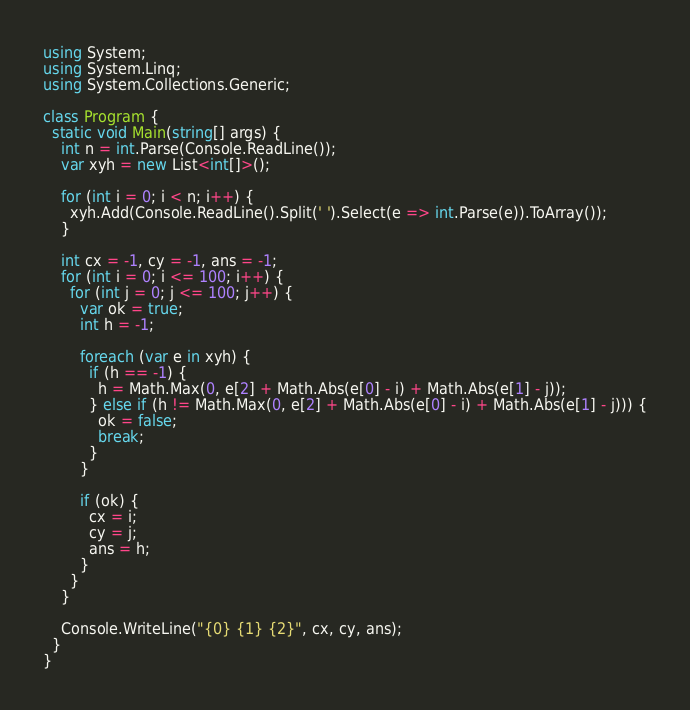<code> <loc_0><loc_0><loc_500><loc_500><_C#_>using System;
using System.Linq;
using System.Collections.Generic;

class Program {
  static void Main(string[] args) {
    int n = int.Parse(Console.ReadLine());
    var xyh = new List<int[]>();

    for (int i = 0; i < n; i++) {
      xyh.Add(Console.ReadLine().Split(' ').Select(e => int.Parse(e)).ToArray());
    }

    int cx = -1, cy = -1, ans = -1;
    for (int i = 0; i <= 100; i++) {
      for (int j = 0; j <= 100; j++) {
        var ok = true;
        int h = -1;

        foreach (var e in xyh) {
          if (h == -1) {
            h = Math.Max(0, e[2] + Math.Abs(e[0] - i) + Math.Abs(e[1] - j));
          } else if (h != Math.Max(0, e[2] + Math.Abs(e[0] - i) + Math.Abs(e[1] - j))) {
            ok = false;
            break;
          }
        }

        if (ok) {
          cx = i;
          cy = j;
          ans = h;
        }
      }
    }

    Console.WriteLine("{0} {1} {2}", cx, cy, ans);
  }
}
</code> 